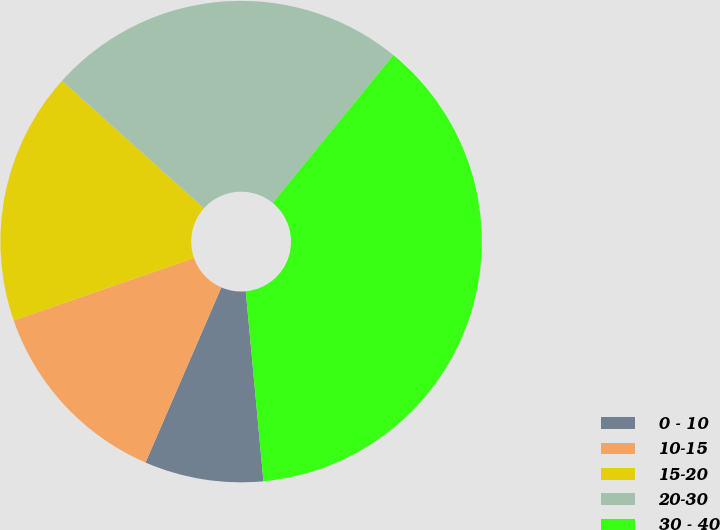Convert chart to OTSL. <chart><loc_0><loc_0><loc_500><loc_500><pie_chart><fcel>0 - 10<fcel>10-15<fcel>15-20<fcel>20-30<fcel>30 - 40<nl><fcel>7.98%<fcel>13.19%<fcel>16.96%<fcel>24.25%<fcel>37.63%<nl></chart> 